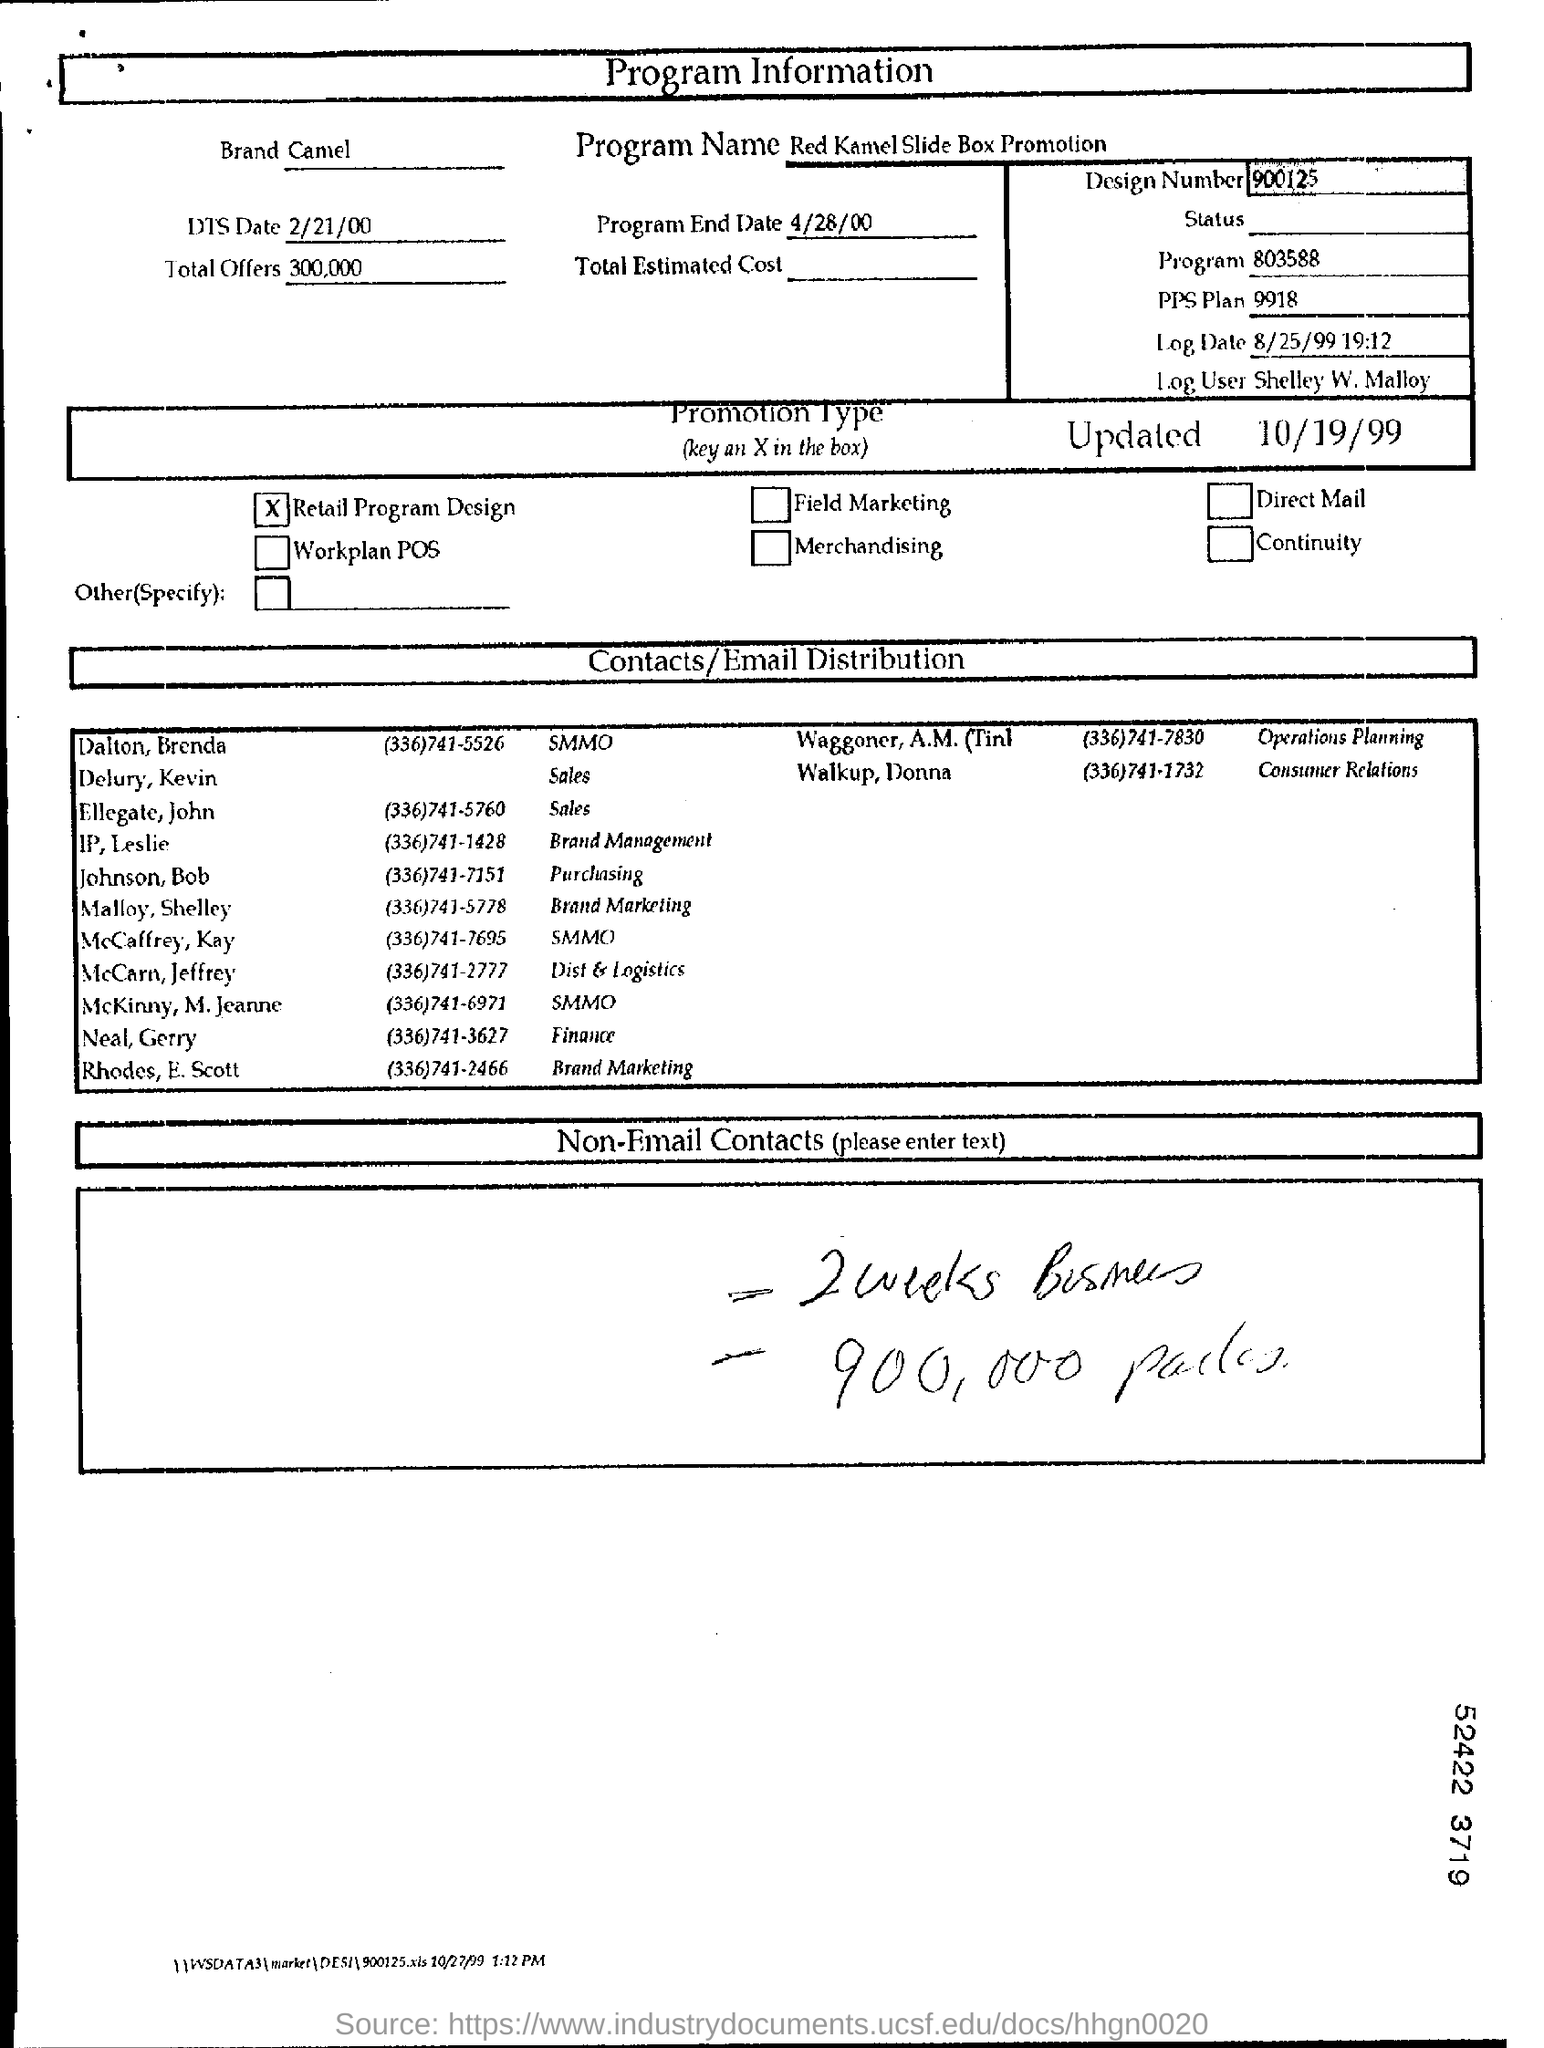What is the date of dts?
Provide a short and direct response. 2/21/00. What are the total offers?
Make the answer very short. 300,000. What is the name of prograam?
Provide a short and direct response. Red kamel slide box promotion. What is the design number ?
Your answer should be compact. 900125. What is the PPS Plan?
Offer a very short reply. 9918. What is the contact number of the malloy, shalley?
Your answer should be very brief. (336)741-5778. 